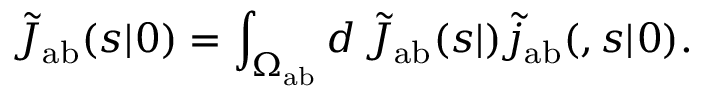Convert formula to latex. <formula><loc_0><loc_0><loc_500><loc_500>\tilde { J } _ { a b } ( s | \ r _ { 0 } ) = \int _ { \Omega _ { a b } } d \ r \, \tilde { J } _ { a b } ( s | \ r ) \tilde { j } _ { a b } ( \ r , s | \ r _ { 0 } ) .</formula> 